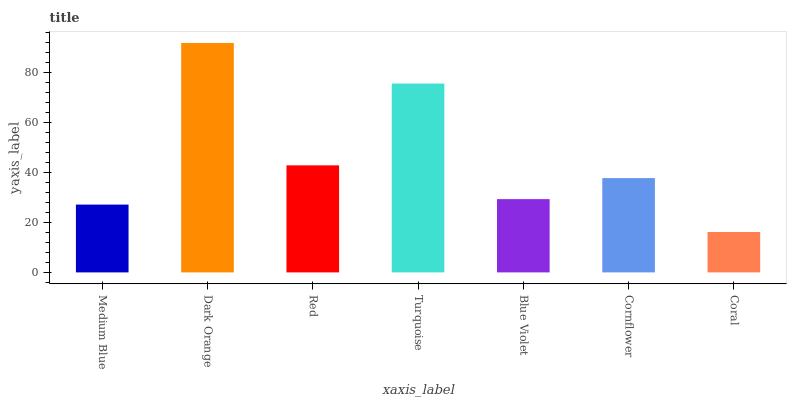Is Coral the minimum?
Answer yes or no. Yes. Is Dark Orange the maximum?
Answer yes or no. Yes. Is Red the minimum?
Answer yes or no. No. Is Red the maximum?
Answer yes or no. No. Is Dark Orange greater than Red?
Answer yes or no. Yes. Is Red less than Dark Orange?
Answer yes or no. Yes. Is Red greater than Dark Orange?
Answer yes or no. No. Is Dark Orange less than Red?
Answer yes or no. No. Is Cornflower the high median?
Answer yes or no. Yes. Is Cornflower the low median?
Answer yes or no. Yes. Is Medium Blue the high median?
Answer yes or no. No. Is Blue Violet the low median?
Answer yes or no. No. 